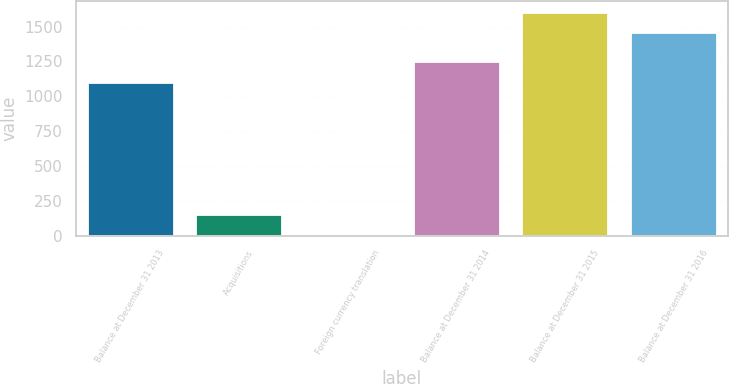Convert chart. <chart><loc_0><loc_0><loc_500><loc_500><bar_chart><fcel>Balance at December 31 2013<fcel>Acquisitions<fcel>Foreign currency translation<fcel>Balance at December 31 2014<fcel>Balance at December 31 2015<fcel>Balance at December 31 2016<nl><fcel>1104<fcel>153.5<fcel>6<fcel>1251.5<fcel>1605.5<fcel>1458<nl></chart> 